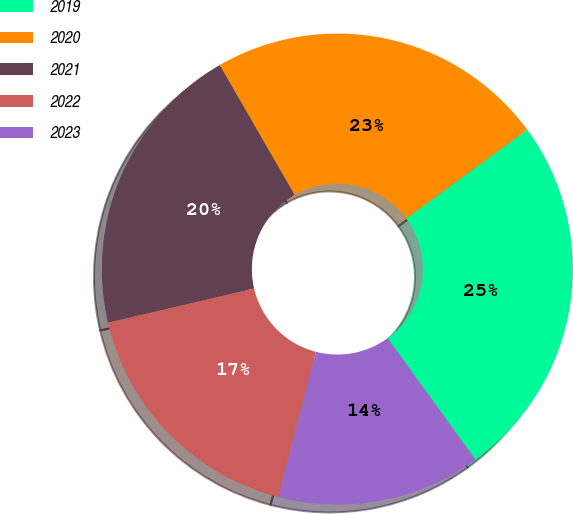<chart> <loc_0><loc_0><loc_500><loc_500><pie_chart><fcel>2019<fcel>2020<fcel>2021<fcel>2022<fcel>2023<nl><fcel>25.1%<fcel>23.24%<fcel>20.33%<fcel>17.32%<fcel>14.01%<nl></chart> 